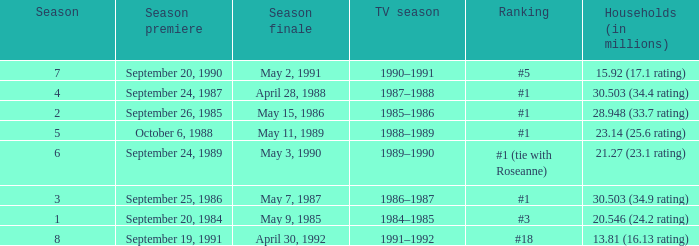Which TV season has a Season larger than 2, and a Ranking of #5? 1990–1991. 